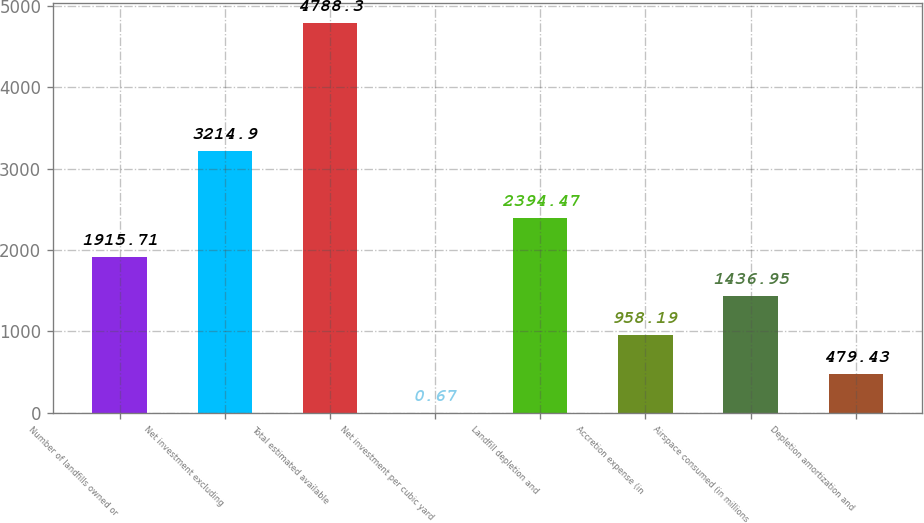<chart> <loc_0><loc_0><loc_500><loc_500><bar_chart><fcel>Number of landfills owned or<fcel>Net investment excluding<fcel>Total estimated available<fcel>Net investment per cubic yard<fcel>Landfill depletion and<fcel>Accretion expense (in<fcel>Airspace consumed (in millions<fcel>Depletion amortization and<nl><fcel>1915.71<fcel>3214.9<fcel>4788.3<fcel>0.67<fcel>2394.47<fcel>958.19<fcel>1436.95<fcel>479.43<nl></chart> 